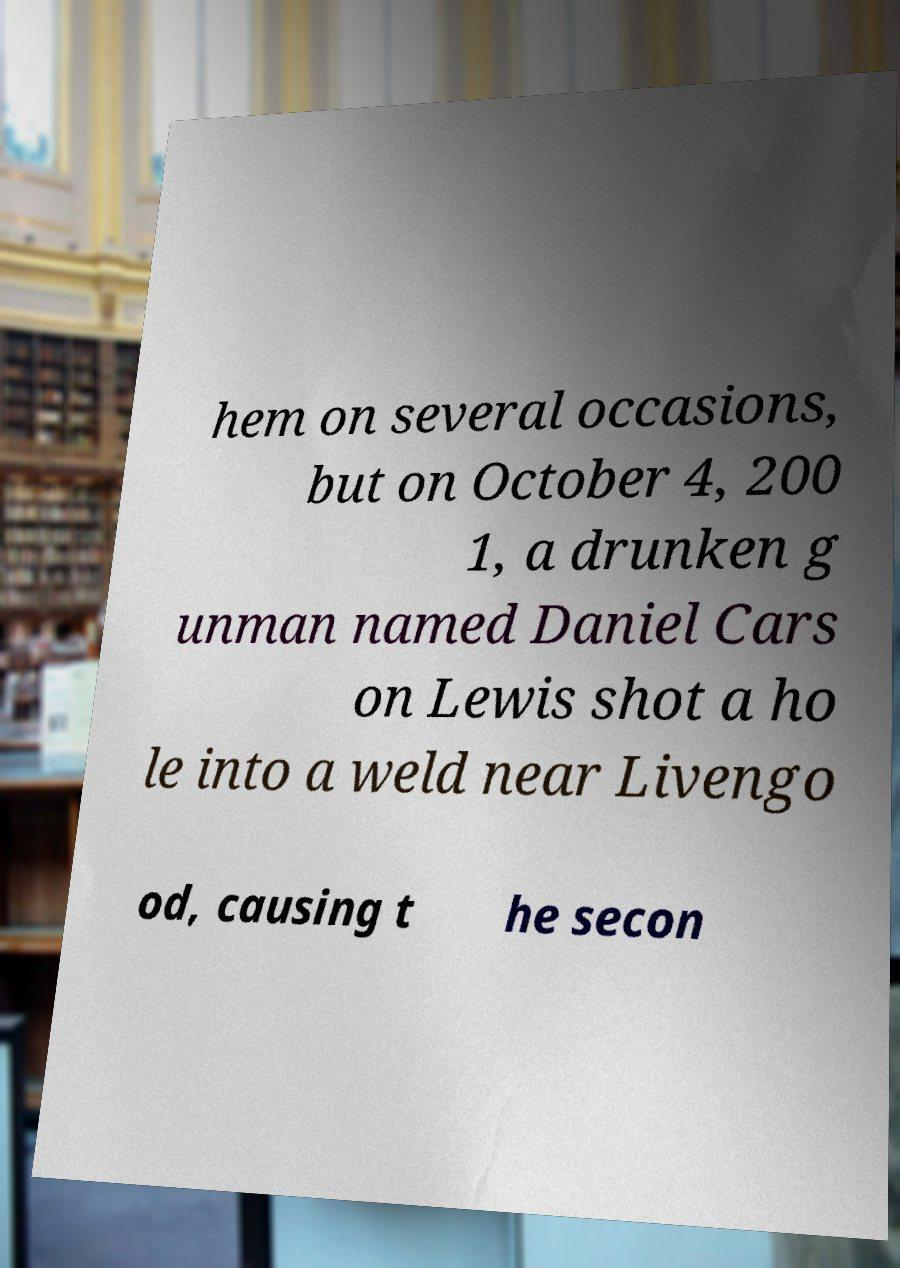There's text embedded in this image that I need extracted. Can you transcribe it verbatim? hem on several occasions, but on October 4, 200 1, a drunken g unman named Daniel Cars on Lewis shot a ho le into a weld near Livengo od, causing t he secon 